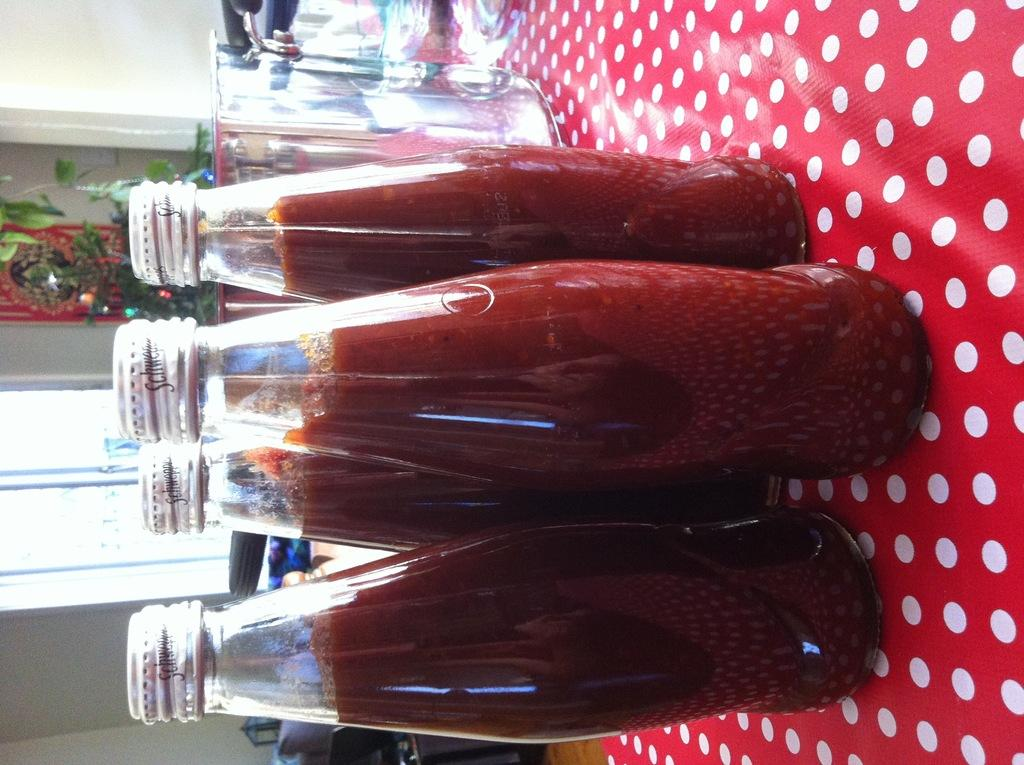What objects are on the table in the image? There are bottles on the table in the image. What material is the table made of? The table is made of glass. What can be seen in the background of the image? There is a wall and a window in the background of the image. What type of vegetation is present in the image? There is a plant in the image. What time is displayed on the clock in the image? There is no clock present in the image. How many matches are visible in the image? There are no matches visible in the image. 